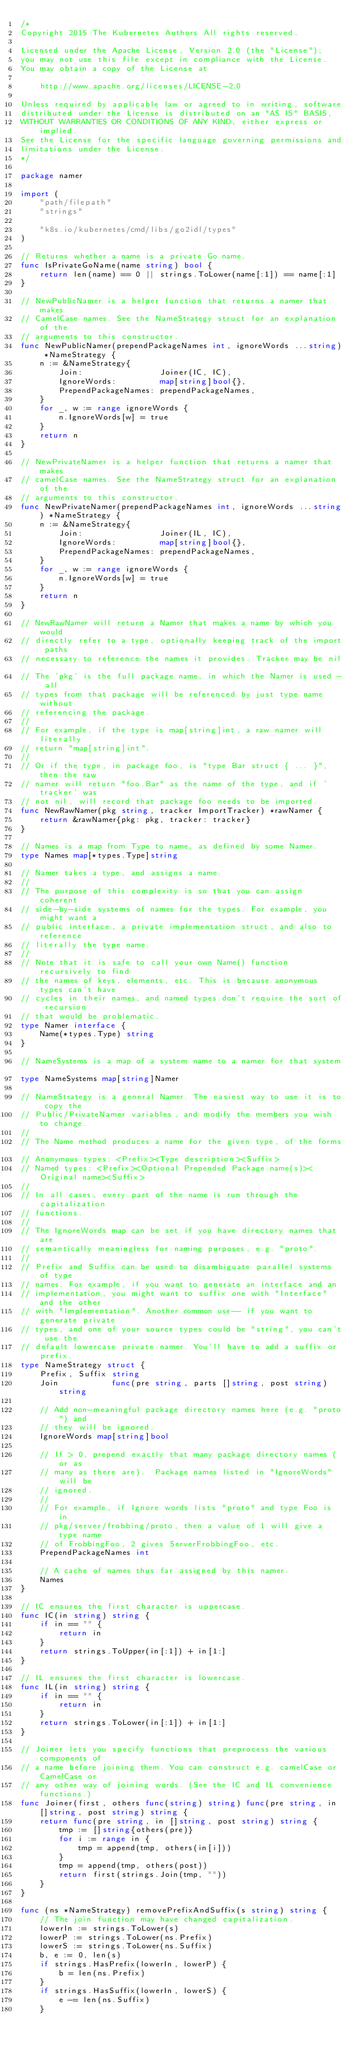<code> <loc_0><loc_0><loc_500><loc_500><_Go_>/*
Copyright 2015 The Kubernetes Authors All rights reserved.

Licensed under the Apache License, Version 2.0 (the "License");
you may not use this file except in compliance with the License.
You may obtain a copy of the License at

    http://www.apache.org/licenses/LICENSE-2.0

Unless required by applicable law or agreed to in writing, software
distributed under the License is distributed on an "AS IS" BASIS,
WITHOUT WARRANTIES OR CONDITIONS OF ANY KIND, either express or implied.
See the License for the specific language governing permissions and
limitations under the License.
*/

package namer

import (
	"path/filepath"
	"strings"

	"k8s.io/kubernetes/cmd/libs/go2idl/types"
)

// Returns whether a name is a private Go name.
func IsPrivateGoName(name string) bool {
	return len(name) == 0 || strings.ToLower(name[:1]) == name[:1]
}

// NewPublicNamer is a helper function that returns a namer that makes
// CamelCase names. See the NameStrategy struct for an explanation of the
// arguments to this constructor.
func NewPublicNamer(prependPackageNames int, ignoreWords ...string) *NameStrategy {
	n := &NameStrategy{
		Join:                Joiner(IC, IC),
		IgnoreWords:         map[string]bool{},
		PrependPackageNames: prependPackageNames,
	}
	for _, w := range ignoreWords {
		n.IgnoreWords[w] = true
	}
	return n
}

// NewPrivateNamer is a helper function that returns a namer that makes
// camelCase names. See the NameStrategy struct for an explanation of the
// arguments to this constructor.
func NewPrivateNamer(prependPackageNames int, ignoreWords ...string) *NameStrategy {
	n := &NameStrategy{
		Join:                Joiner(IL, IC),
		IgnoreWords:         map[string]bool{},
		PrependPackageNames: prependPackageNames,
	}
	for _, w := range ignoreWords {
		n.IgnoreWords[w] = true
	}
	return n
}

// NewRawNamer will return a Namer that makes a name by which you would
// directly refer to a type, optionally keeping track of the import paths
// necessary to reference the names it provides. Tracker may be nil.
// The 'pkg' is the full package name, in which the Namer is used - all
// types from that package will be referenced by just type name without
// referencing the package.
//
// For example, if the type is map[string]int, a raw namer will literally
// return "map[string]int".
//
// Or if the type, in package foo, is "type Bar struct { ... }", then the raw
// namer will return "foo.Bar" as the name of the type, and if 'tracker' was
// not nil, will record that package foo needs to be imported.
func NewRawNamer(pkg string, tracker ImportTracker) *rawNamer {
	return &rawNamer{pkg: pkg, tracker: tracker}
}

// Names is a map from Type to name, as defined by some Namer.
type Names map[*types.Type]string

// Namer takes a type, and assigns a name.
//
// The purpose of this complexity is so that you can assign coherent
// side-by-side systems of names for the types. For example, you might want a
// public interface, a private implementation struct, and also to reference
// literally the type name.
//
// Note that it is safe to call your own Name() function recursively to find
// the names of keys, elements, etc. This is because anonymous types can't have
// cycles in their names, and named types don't require the sort of recursion
// that would be problematic.
type Namer interface {
	Name(*types.Type) string
}

// NameSystems is a map of a system name to a namer for that system.
type NameSystems map[string]Namer

// NameStrategy is a general Namer. The easiest way to use it is to copy the
// Public/PrivateNamer variables, and modify the members you wish to change.
//
// The Name method produces a name for the given type, of the forms:
// Anonymous types: <Prefix><Type description><Suffix>
// Named types: <Prefix><Optional Prepended Package name(s)><Original name><Suffix>
//
// In all cases, every part of the name is run through the capitalization
// functions.
//
// The IgnoreWords map can be set if you have directory names that are
// semantically meaningless for naming purposes, e.g. "proto".
//
// Prefix and Suffix can be used to disambiguate parallel systems of type
// names. For example, if you want to generate an interface and an
// implementation, you might want to suffix one with "Interface" and the other
// with "Implementation". Another common use-- if you want to generate private
// types, and one of your source types could be "string", you can't use the
// default lowercase private namer. You'll have to add a suffix or prefix.
type NameStrategy struct {
	Prefix, Suffix string
	Join           func(pre string, parts []string, post string) string

	// Add non-meaningful package directory names here (e.g. "proto") and
	// they will be ignored.
	IgnoreWords map[string]bool

	// If > 0, prepend exactly that many package directory names (or as
	// many as there are).  Package names listed in "IgnoreWords" will be
	// ignored.
	//
	// For example, if Ignore words lists "proto" and type Foo is in
	// pkg/server/frobbing/proto, then a value of 1 will give a type name
	// of FrobbingFoo, 2 gives ServerFrobbingFoo, etc.
	PrependPackageNames int

	// A cache of names thus far assigned by this namer.
	Names
}

// IC ensures the first character is uppercase.
func IC(in string) string {
	if in == "" {
		return in
	}
	return strings.ToUpper(in[:1]) + in[1:]
}

// IL ensures the first character is lowercase.
func IL(in string) string {
	if in == "" {
		return in
	}
	return strings.ToLower(in[:1]) + in[1:]
}

// Joiner lets you specify functions that preprocess the various components of
// a name before joining them. You can construct e.g. camelCase or CamelCase or
// any other way of joining words. (See the IC and IL convenience functions.)
func Joiner(first, others func(string) string) func(pre string, in []string, post string) string {
	return func(pre string, in []string, post string) string {
		tmp := []string{others(pre)}
		for i := range in {
			tmp = append(tmp, others(in[i]))
		}
		tmp = append(tmp, others(post))
		return first(strings.Join(tmp, ""))
	}
}

func (ns *NameStrategy) removePrefixAndSuffix(s string) string {
	// The join function may have changed capitalization.
	lowerIn := strings.ToLower(s)
	lowerP := strings.ToLower(ns.Prefix)
	lowerS := strings.ToLower(ns.Suffix)
	b, e := 0, len(s)
	if strings.HasPrefix(lowerIn, lowerP) {
		b = len(ns.Prefix)
	}
	if strings.HasSuffix(lowerIn, lowerS) {
		e -= len(ns.Suffix)
	}</code> 